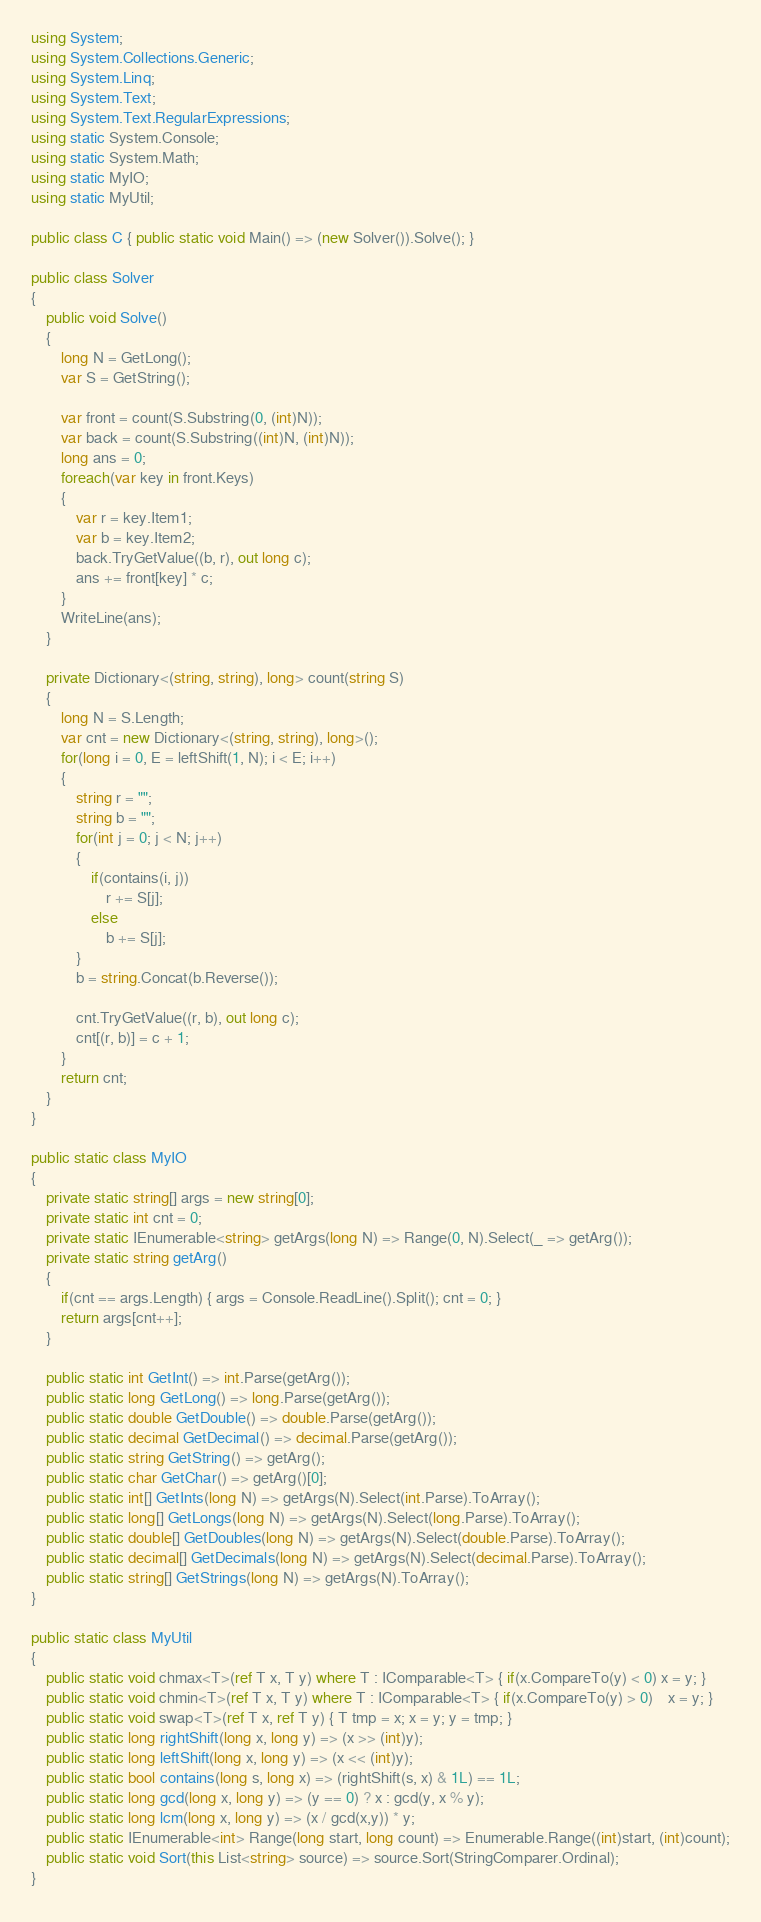Convert code to text. <code><loc_0><loc_0><loc_500><loc_500><_C#_>using System;
using System.Collections.Generic;
using System.Linq;
using System.Text;
using System.Text.RegularExpressions;
using static System.Console;
using static System.Math;
using static MyIO;
using static MyUtil;

public class C { public static void Main() => (new Solver()).Solve(); }

public class Solver
{
	public void Solve()
	{
		long N = GetLong();
		var S = GetString();

		var front = count(S.Substring(0, (int)N));
		var back = count(S.Substring((int)N, (int)N));
		long ans = 0;
		foreach(var key in front.Keys)
		{
			var r = key.Item1;
			var b = key.Item2;
			back.TryGetValue((b, r), out long c);
			ans += front[key] * c;
		}
		WriteLine(ans);
	}
	
	private Dictionary<(string, string), long> count(string S)
	{
		long N = S.Length;
		var cnt = new Dictionary<(string, string), long>();
		for(long i = 0, E = leftShift(1, N); i < E; i++)
		{
			string r = "";
			string b = "";
			for(int j = 0; j < N; j++)
			{
				if(contains(i, j))
					r += S[j];
				else
					b += S[j];
			}
			b = string.Concat(b.Reverse());

			cnt.TryGetValue((r, b), out long c);
			cnt[(r, b)] = c + 1;
		}
		return cnt;
	}
}

public static class MyIO
{
	private static string[] args = new string[0];
	private static int cnt = 0;
	private static IEnumerable<string> getArgs(long N) => Range(0, N).Select(_ => getArg());
	private static string getArg()
	{
		if(cnt == args.Length) { args = Console.ReadLine().Split(); cnt = 0; }
		return args[cnt++];
	}

	public static int GetInt() => int.Parse(getArg());
	public static long GetLong() => long.Parse(getArg());
	public static double GetDouble() => double.Parse(getArg());
	public static decimal GetDecimal() => decimal.Parse(getArg());
	public static string GetString() => getArg();
	public static char GetChar() => getArg()[0];
	public static int[] GetInts(long N) => getArgs(N).Select(int.Parse).ToArray();
	public static long[] GetLongs(long N) => getArgs(N).Select(long.Parse).ToArray();
	public static double[] GetDoubles(long N) => getArgs(N).Select(double.Parse).ToArray();
	public static decimal[] GetDecimals(long N) => getArgs(N).Select(decimal.Parse).ToArray();
	public static string[] GetStrings(long N) => getArgs(N).ToArray();
}

public static class MyUtil
{
	public static void chmax<T>(ref T x, T y) where T : IComparable<T> { if(x.CompareTo(y) < 0) x = y; }
	public static void chmin<T>(ref T x, T y) where T : IComparable<T> { if(x.CompareTo(y) > 0)	x = y; }
	public static void swap<T>(ref T x, ref T y) { T tmp = x; x = y; y = tmp; }
	public static long rightShift(long x, long y) => (x >> (int)y);
	public static long leftShift(long x, long y) => (x << (int)y);
	public static bool contains(long s, long x) => (rightShift(s, x) & 1L) == 1L;
	public static long gcd(long x, long y) => (y == 0) ? x : gcd(y, x % y);
	public static long lcm(long x, long y) => (x / gcd(x,y)) * y;	
	public static IEnumerable<int> Range(long start, long count) => Enumerable.Range((int)start, (int)count);
	public static void Sort(this List<string> source) => source.Sort(StringComparer.Ordinal);
}
</code> 